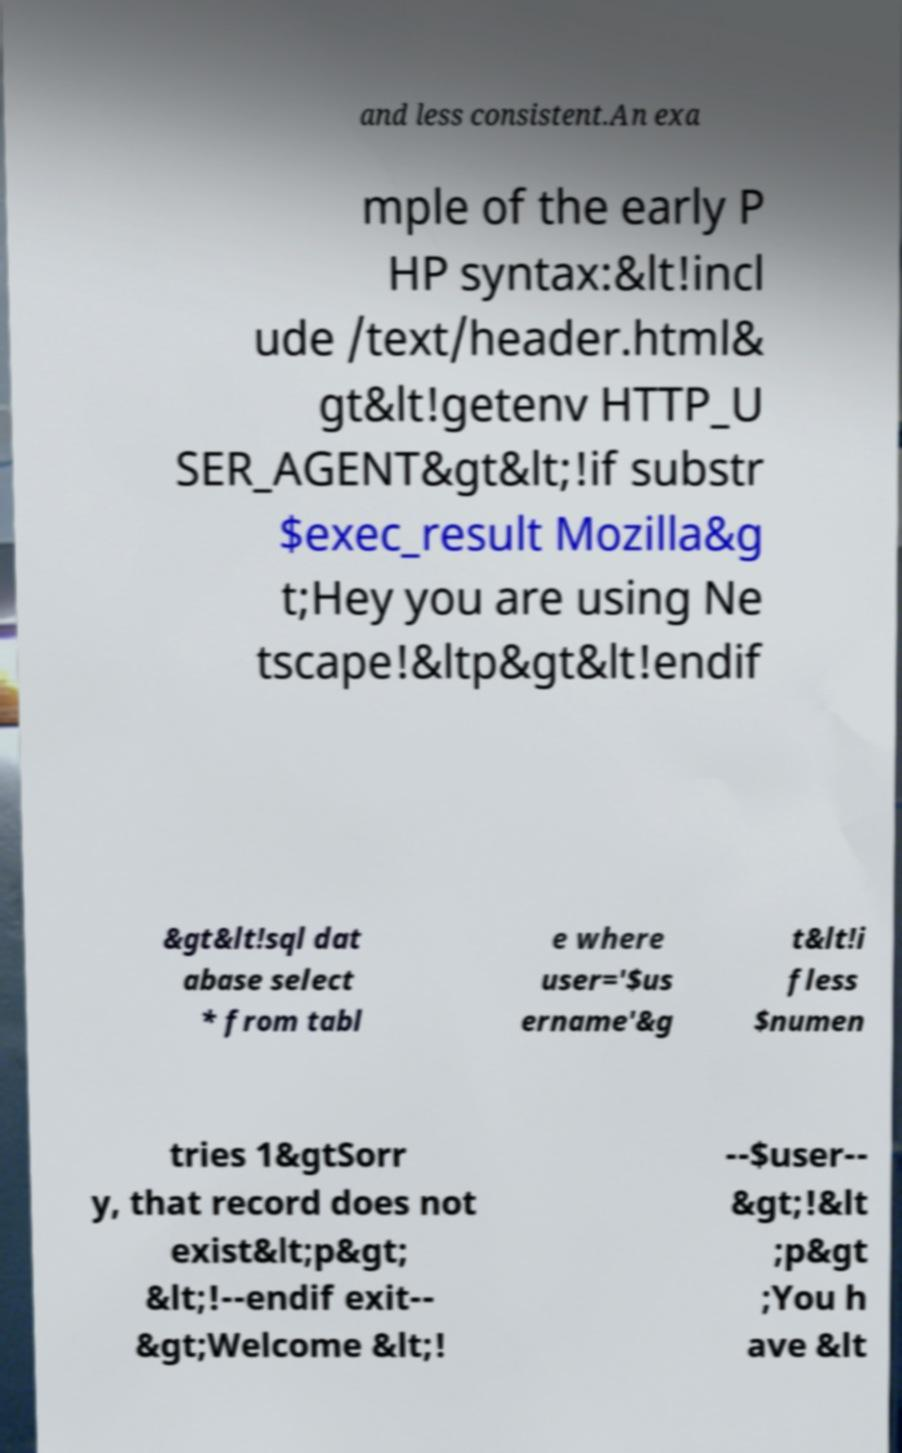I need the written content from this picture converted into text. Can you do that? and less consistent.An exa mple of the early P HP syntax:&lt!incl ude /text/header.html& gt&lt!getenv HTTP_U SER_AGENT&gt&lt;!if substr $exec_result Mozilla&g t;Hey you are using Ne tscape!&ltp&gt&lt!endif &gt&lt!sql dat abase select * from tabl e where user='$us ername'&g t&lt!i fless $numen tries 1&gtSorr y, that record does not exist&lt;p&gt; &lt;!--endif exit-- &gt;Welcome &lt;! --$user-- &gt;!&lt ;p&gt ;You h ave &lt 